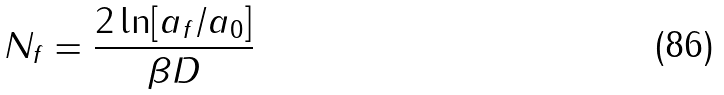Convert formula to latex. <formula><loc_0><loc_0><loc_500><loc_500>N _ { f } = \frac { 2 \ln [ a _ { f } / a _ { 0 } ] } { \beta D }</formula> 